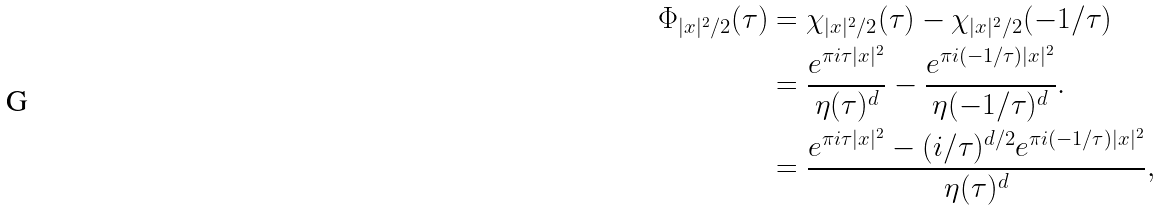Convert formula to latex. <formula><loc_0><loc_0><loc_500><loc_500>\Phi _ { | x | ^ { 2 } / 2 } ( \tau ) & = \chi _ { | x | ^ { 2 } / 2 } ( \tau ) - \chi _ { | x | ^ { 2 } / 2 } ( - 1 / \tau ) \\ & = \frac { e ^ { \pi i \tau | x | ^ { 2 } } } { \eta ( \tau ) ^ { d } } - \frac { e ^ { \pi i ( - 1 / \tau ) | x | ^ { 2 } } } { \eta ( - 1 / \tau ) ^ { d } } . \\ & = \frac { e ^ { \pi i \tau | x | ^ { 2 } } - ( i / \tau ) ^ { d / 2 } e ^ { \pi i ( - 1 / \tau ) | x | ^ { 2 } } } { \eta ( \tau ) ^ { d } } ,</formula> 